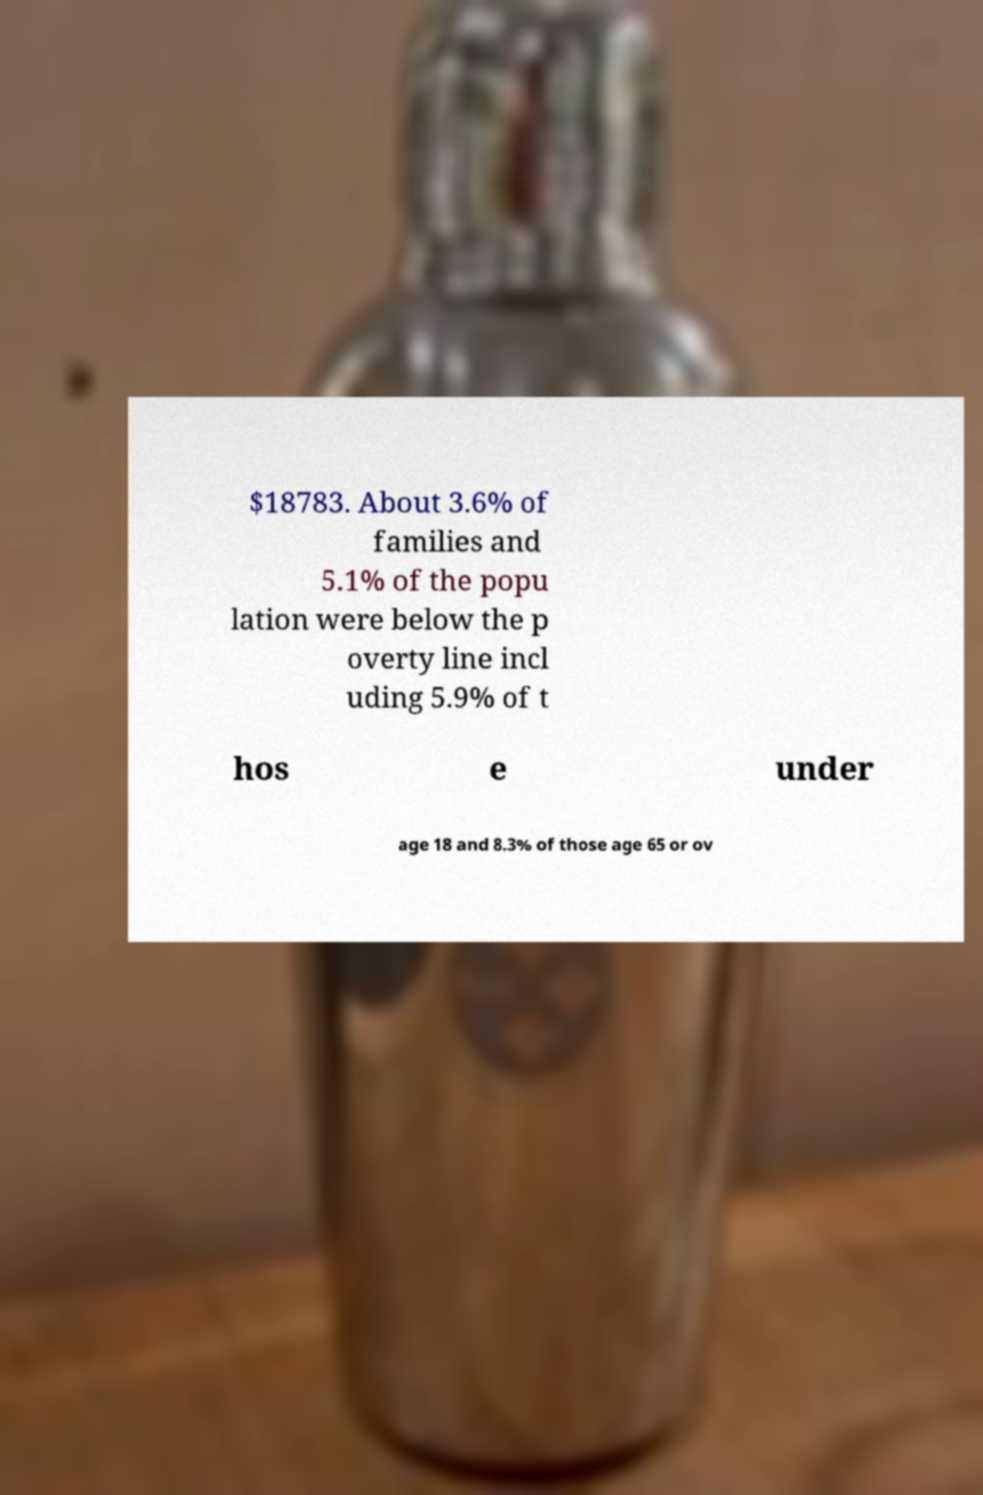Can you accurately transcribe the text from the provided image for me? $18783. About 3.6% of families and 5.1% of the popu lation were below the p overty line incl uding 5.9% of t hos e under age 18 and 8.3% of those age 65 or ov 